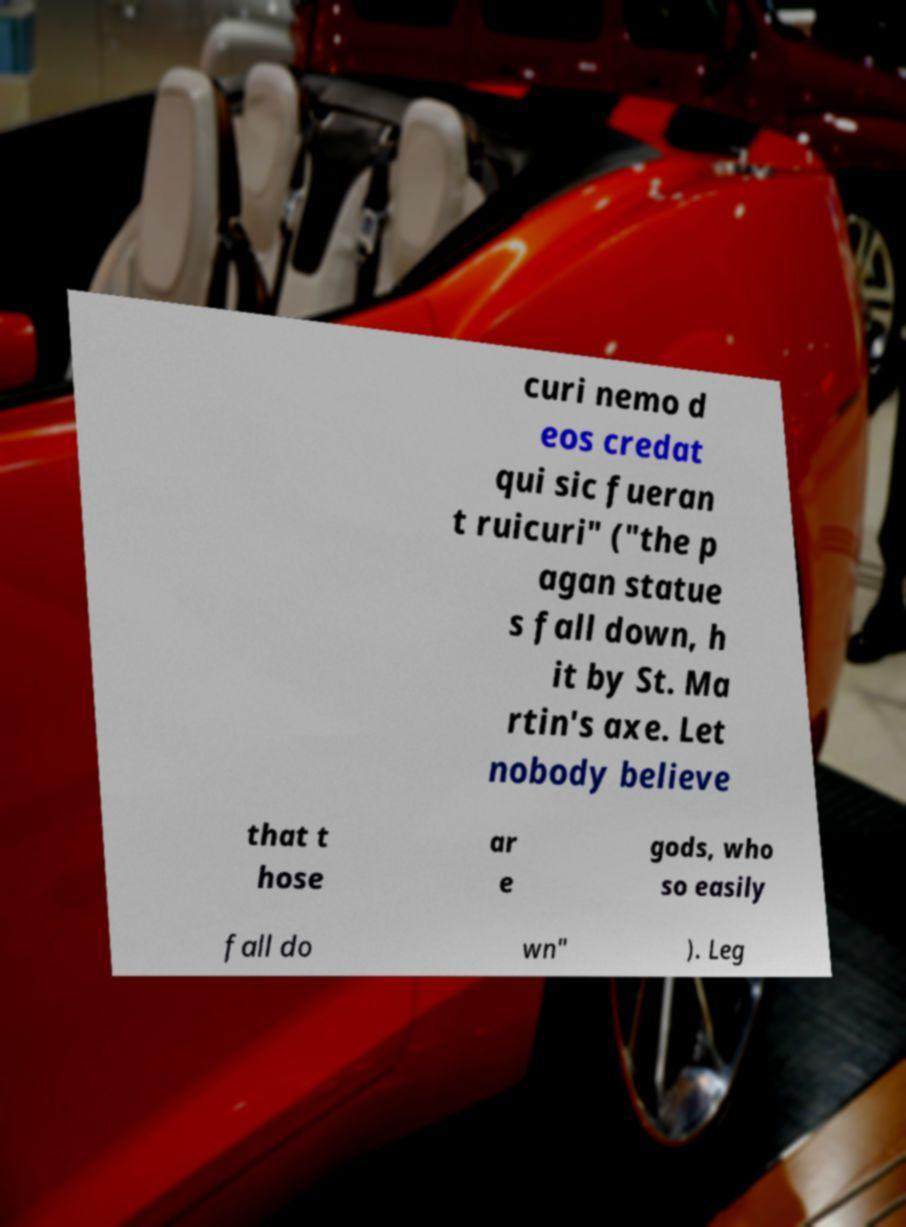I need the written content from this picture converted into text. Can you do that? curi nemo d eos credat qui sic fueran t ruicuri" ("the p agan statue s fall down, h it by St. Ma rtin's axe. Let nobody believe that t hose ar e gods, who so easily fall do wn" ). Leg 